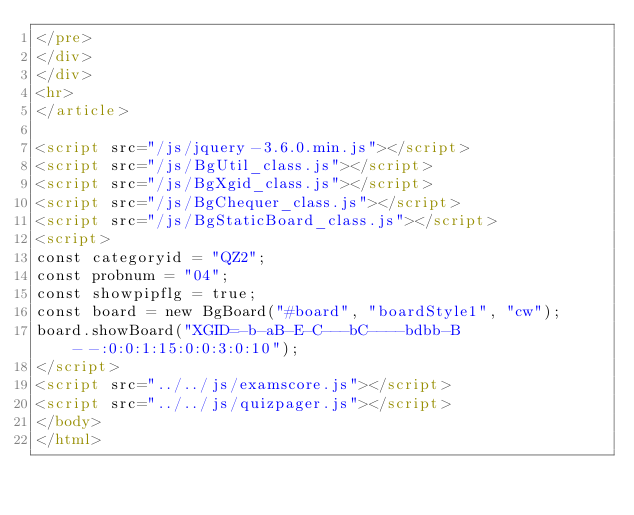Convert code to text. <code><loc_0><loc_0><loc_500><loc_500><_HTML_></pre>
</div>
</div>
<hr>
</article>

<script src="/js/jquery-3.6.0.min.js"></script>
<script src="/js/BgUtil_class.js"></script>
<script src="/js/BgXgid_class.js"></script>
<script src="/js/BgChequer_class.js"></script>
<script src="/js/BgStaticBoard_class.js"></script>
<script>
const categoryid = "QZ2";
const probnum = "04";
const showpipflg = true;
const board = new BgBoard("#board", "boardStyle1", "cw");
board.showBoard("XGID=-b-aB-E-C---bC----bdbb-B--:0:0:1:15:0:0:3:0:10");
</script>
<script src="../../js/examscore.js"></script>
<script src="../../js/quizpager.js"></script>
</body>
</html>
</code> 